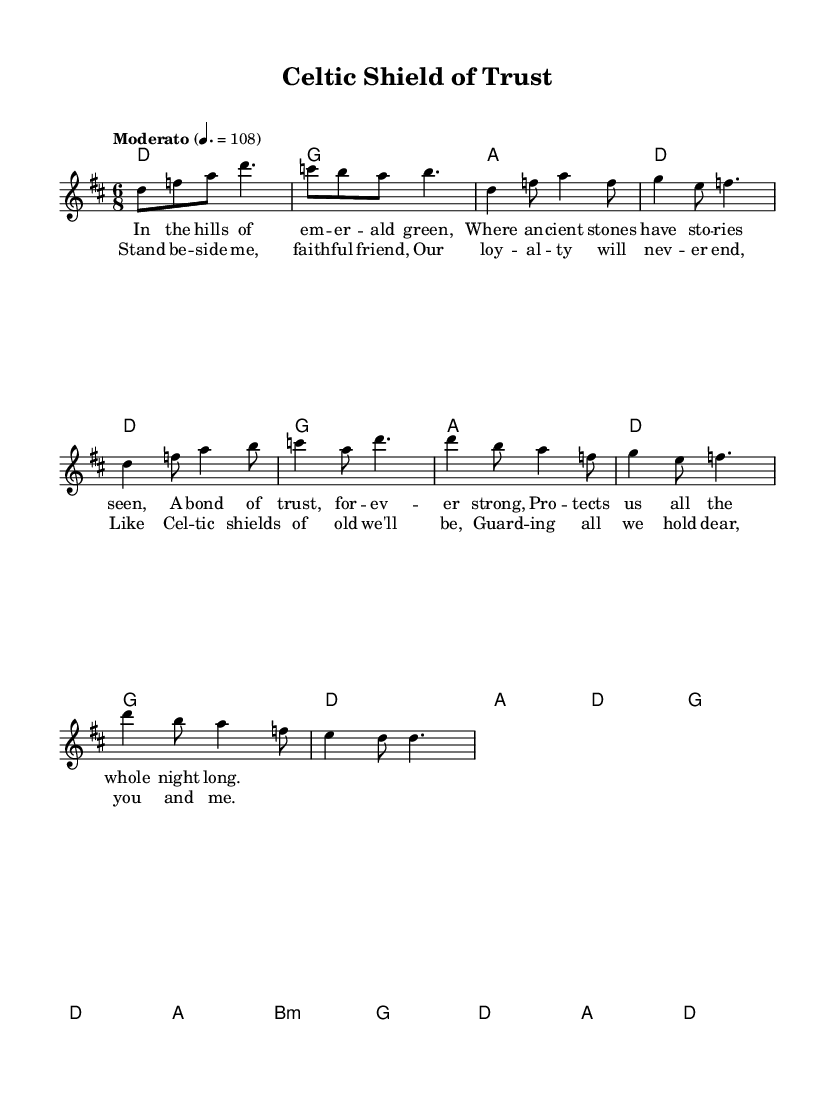What is the key signature of this music? The key signature is indicated at the beginning of the score with a "D" on the staff, suggesting two sharps (F# and C#).
Answer: D major What is the time signature of this piece? The time signature is shown at the start of the score as "6/8," indicating six eighth notes per measure.
Answer: 6/8 What is the tempo marking for this music? The tempo marking is specified as "Moderato" with a set metronome mark of 108, indicating a moderately paced speed.
Answer: Moderato 108 How many measures are in the intro section? By counting the measures represented in the intro part of the score, we see there are four measures before transitioning to the verse.
Answer: 4 What is the main theme represented in the lyrics? The lyrics express loyalty and protection, emphasizing the bond of trust and companionship, which is implied throughout the verses and chorus.
Answer: Loyalty and protection What chord follows the chorus in the chord progression? The last chord listed in the chorus section, after the final lyric line, is marked as D, indicating it concludes with this landing tone.
Answer: D How does the structure of this piece reflect traditional Celtic music themes? The structure includes verses and a chorus, typical for folk music, while the lyrical content is centered around loyalty and protection, common themes in Celtic traditions.
Answer: Traditional folk structure 